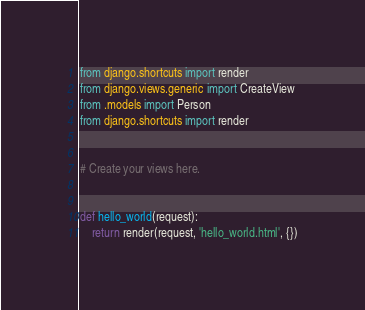Convert code to text. <code><loc_0><loc_0><loc_500><loc_500><_Python_>from django.shortcuts import render
from django.views.generic import CreateView
from .models import Person
from django.shortcuts import render


# Create your views here.


def hello_world(request):
    return render(request, 'hello_world.html', {})
</code> 